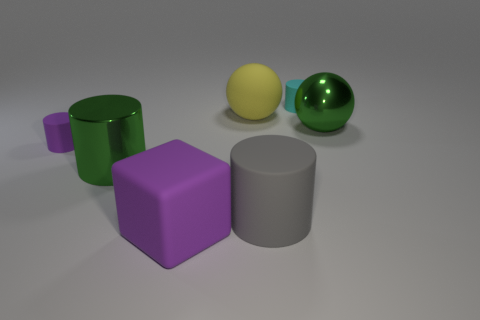Add 3 green metal things. How many objects exist? 10 Subtract all cylinders. How many objects are left? 3 Subtract 1 yellow balls. How many objects are left? 6 Subtract all yellow rubber things. Subtract all big cylinders. How many objects are left? 4 Add 1 green balls. How many green balls are left? 2 Add 7 matte spheres. How many matte spheres exist? 8 